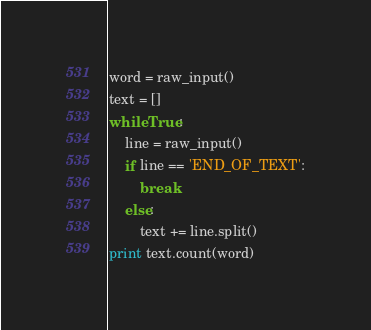<code> <loc_0><loc_0><loc_500><loc_500><_Python_>word = raw_input()
text = []
while True:
    line = raw_input()
    if line == 'END_OF_TEXT':
        break
    else:
        text += line.split()
print text.count(word)</code> 